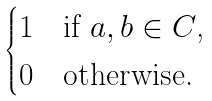<formula> <loc_0><loc_0><loc_500><loc_500>\begin{cases} 1 & \text {if $a,b\in\mathcal{ }C$, } \\ 0 & \text {otherwise.} \end{cases}</formula> 